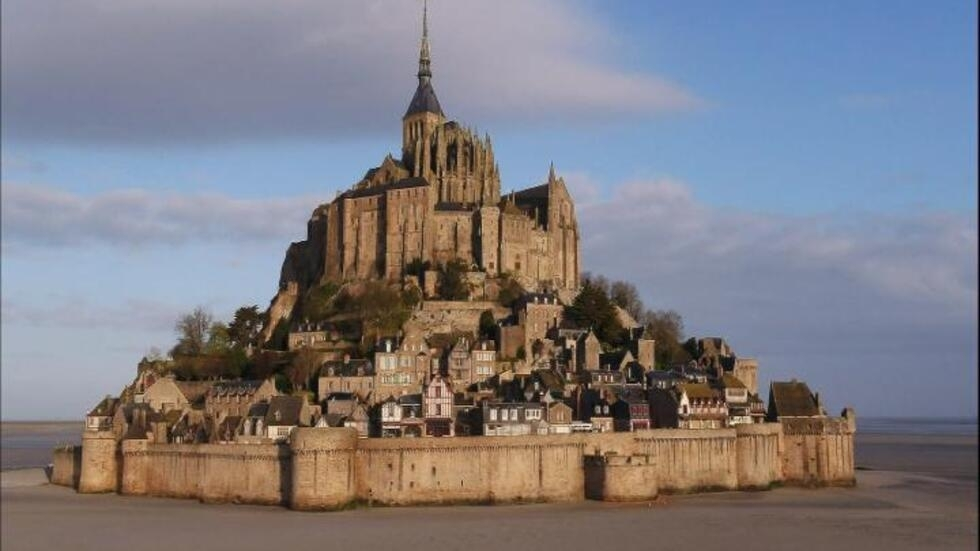What is this photo about? The image showcases the majestic Mont Saint-Michel, an iconic island commune in Normandy, France. Prominently featuring the grand medieval abbey that dominates the island, the photograph captures the beauty and architectural sophistication of this historical monument. The abbey, with its towering spire, is surrounded by robust fortified walls that hint at its storied past. A quaint village nestles within these defenses, adding charm and vibrancy to the scene. The harmonious blend of earthy tones with the serene blue hues of the sky and water creates a picturesque and tranquil view. Overall, the photograph beautifully encapsulates the essence and timeless allure of Mont Saint-Michel, from its historical significance to its scenic splendor. 